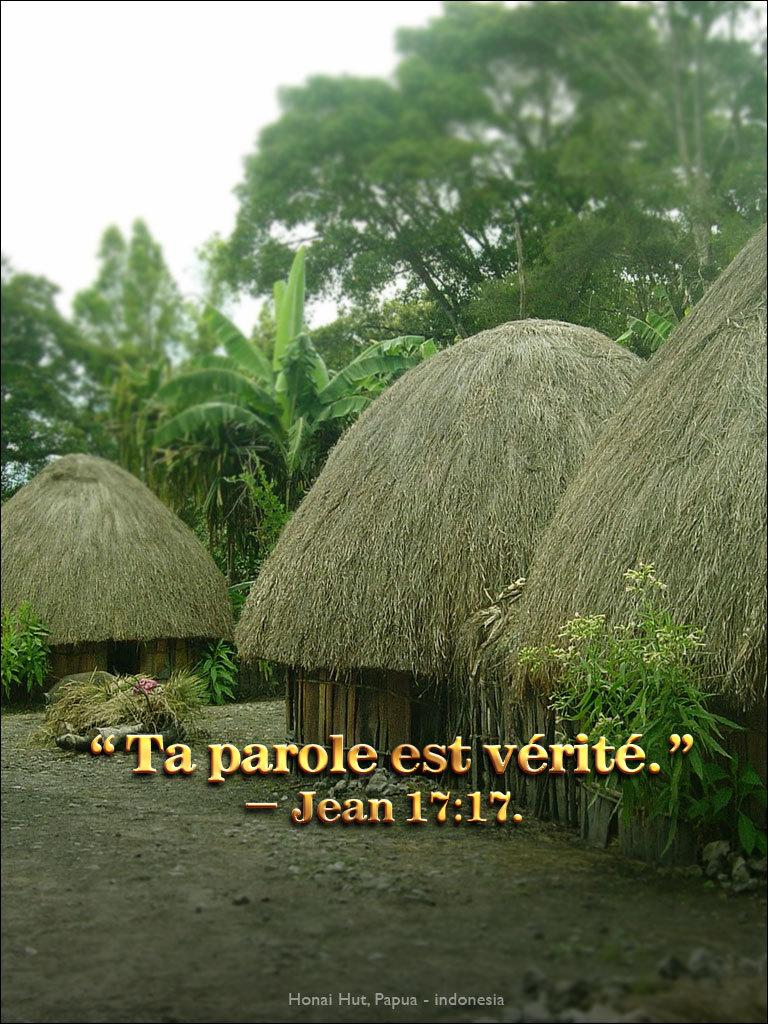What type of vegetation can be seen in the image? There are trees in the image. What structures are located in the middle of the image? There are huts in the middle of the image. What can be seen on the right side of the image? There is a plant on the right side of the image. What part of the sky is visible in the image? The sky is visible in the top left of the image. Can you see a yak walking in the image? There is no yak present in the image. What direction is the head of the train facing in the image? There is no train present in the image. 